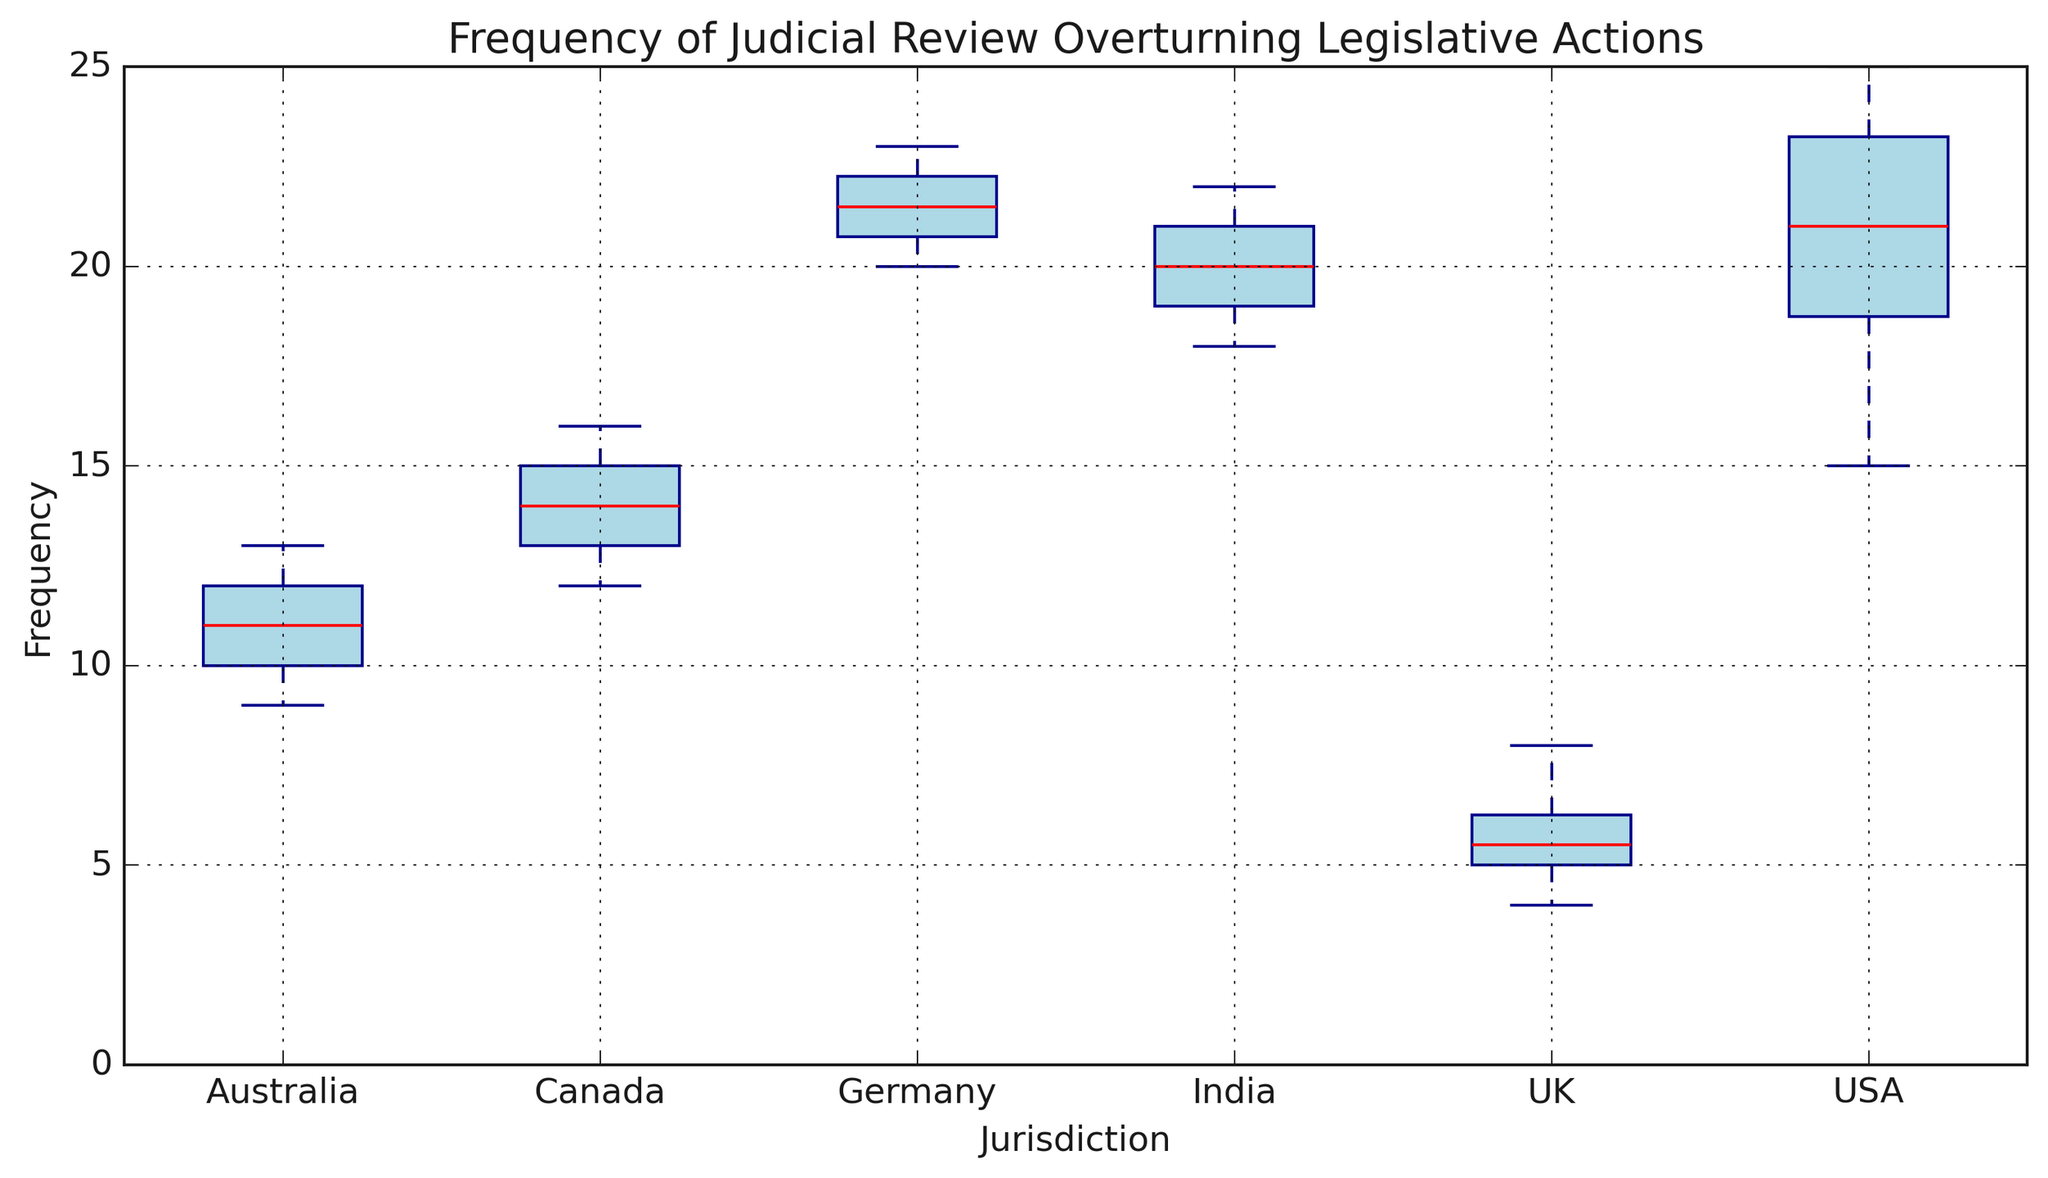What's the median frequency of judicial review overturning legislative actions in the USA? To find the median, sort the frequencies for the USA: [15, 18, 19, 20, 22, 23, 24, 25]. The median is the middle value(s). In this case, the median is the average of the 4th and 5th values: (20 + 22) / 2 = 21
Answer: 21 Which jurisdiction has the highest median frequency of judicial review overturning legislative actions? To identify which jurisdiction has the highest median, observe the horizontal red line (median) in each box plot. Compare the medians for all jurisdictions: USA, UK, Canada, Germany, India, Australia. The median for Germany is the highest.
Answer: Germany How do the interquartile ranges (IQRs) of the UK and Australia compare? The IQR is the range between the first quartile (Q1) and the third quartile (Q3) of the data, represented by the bottom and top of the blue boxes. Visually, compare the height of the blue boxes for the UK and Australia. The box for the UK is shorter than that of Australia, indicating the UK has a smaller IQR.
Answer: The UK's IQR is smaller than Australia's Which jurisdiction has the widest range of judicial review frequencies, and what is it? The range is the difference between the maximum and minimum values (whisker tips). Identify the jurisdiction with the longest whiskers. The USA has a range from 15 to 25. Range = 25 - 15 = 10.
Answer: USA, 10 Is there any overlap in the frequency of judicial reviews between Canada and India? Check if the boxes (IQR) and whiskers (overall range) of Canada and India intersect. Both boxes and whiskers for Canada (12-16) and India (18-22) do not intersect, indicating no overlap.
Answer: No 